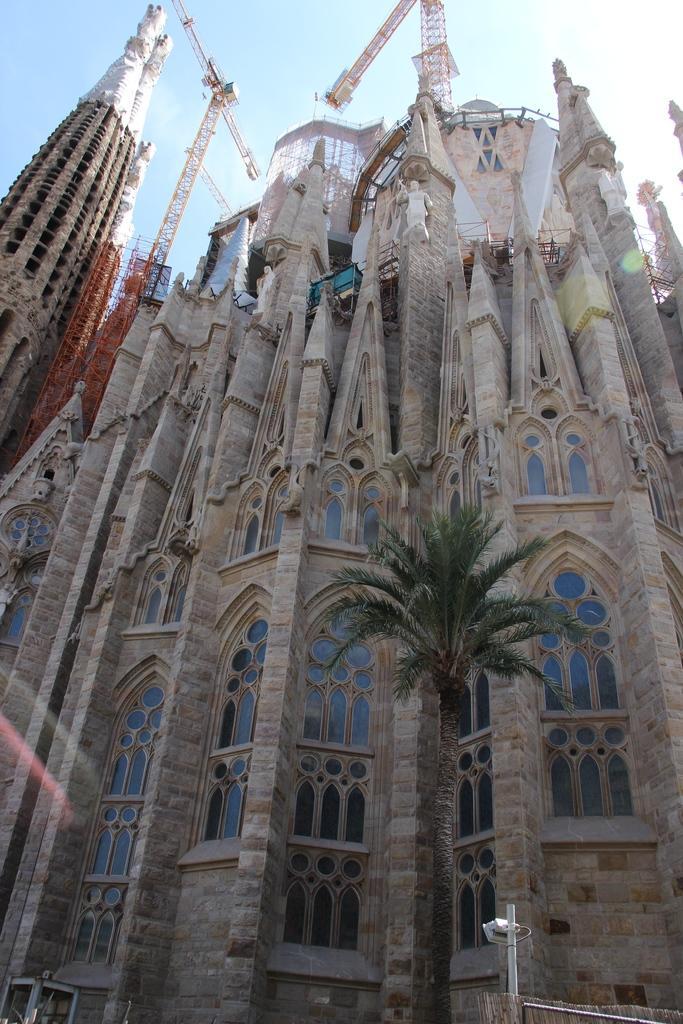Could you give a brief overview of what you see in this image? In the center of the image there are buildings and we can see a crane. At the bottom there is a tree and a pole. At the top there is sky. 